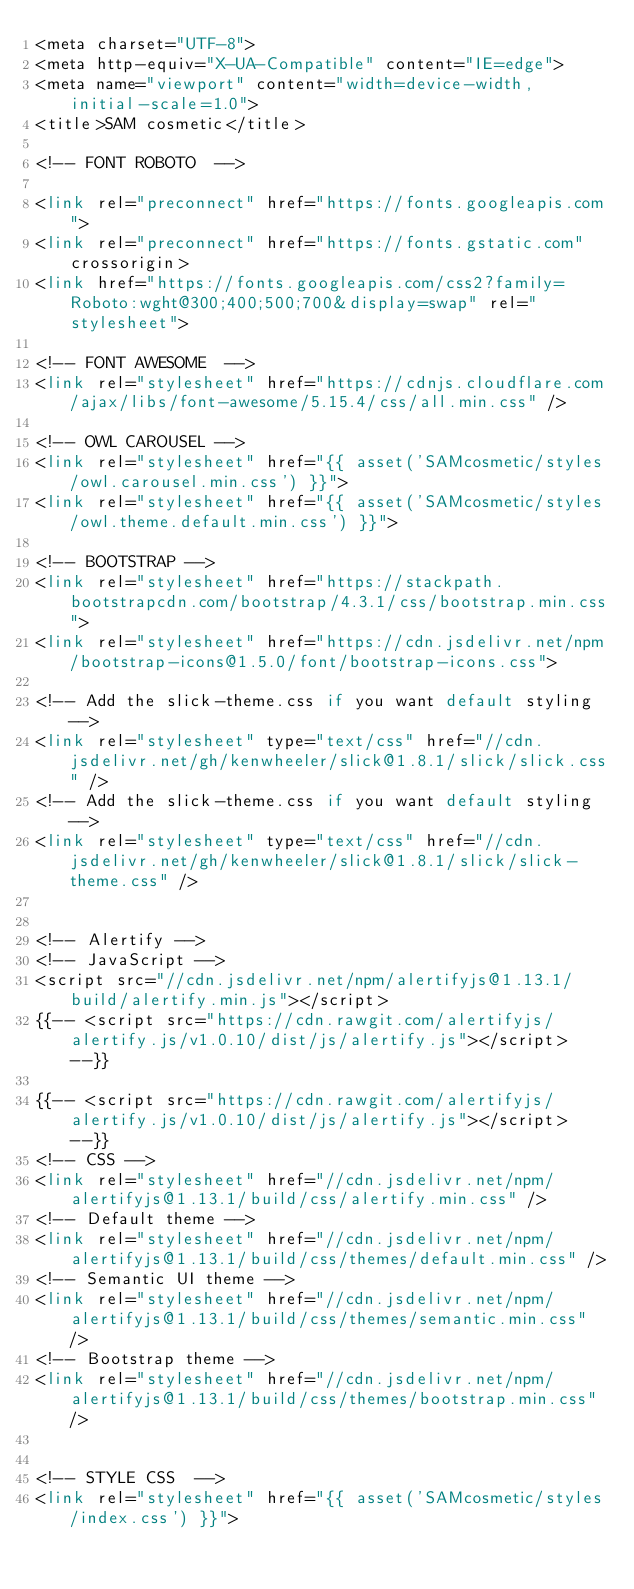Convert code to text. <code><loc_0><loc_0><loc_500><loc_500><_PHP_><meta charset="UTF-8">
<meta http-equiv="X-UA-Compatible" content="IE=edge">
<meta name="viewport" content="width=device-width, initial-scale=1.0">
<title>SAM cosmetic</title>

<!-- FONT ROBOTO  -->

<link rel="preconnect" href="https://fonts.googleapis.com">
<link rel="preconnect" href="https://fonts.gstatic.com" crossorigin>
<link href="https://fonts.googleapis.com/css2?family=Roboto:wght@300;400;500;700&display=swap" rel="stylesheet">

<!-- FONT AWESOME  -->
<link rel="stylesheet" href="https://cdnjs.cloudflare.com/ajax/libs/font-awesome/5.15.4/css/all.min.css" />

<!-- OWL CAROUSEL -->
<link rel="stylesheet" href="{{ asset('SAMcosmetic/styles/owl.carousel.min.css') }}">
<link rel="stylesheet" href="{{ asset('SAMcosmetic/styles/owl.theme.default.min.css') }}">

<!-- BOOTSTRAP -->
<link rel="stylesheet" href="https://stackpath.bootstrapcdn.com/bootstrap/4.3.1/css/bootstrap.min.css">
<link rel="stylesheet" href="https://cdn.jsdelivr.net/npm/bootstrap-icons@1.5.0/font/bootstrap-icons.css">

<!-- Add the slick-theme.css if you want default styling -->
<link rel="stylesheet" type="text/css" href="//cdn.jsdelivr.net/gh/kenwheeler/slick@1.8.1/slick/slick.css" />
<!-- Add the slick-theme.css if you want default styling -->
<link rel="stylesheet" type="text/css" href="//cdn.jsdelivr.net/gh/kenwheeler/slick@1.8.1/slick/slick-theme.css" />


<!-- Alertify -->
<!-- JavaScript -->
<script src="//cdn.jsdelivr.net/npm/alertifyjs@1.13.1/build/alertify.min.js"></script>
{{-- <script src="https://cdn.rawgit.com/alertifyjs/alertify.js/v1.0.10/dist/js/alertify.js"></script> --}}

{{-- <script src="https://cdn.rawgit.com/alertifyjs/alertify.js/v1.0.10/dist/js/alertify.js"></script> --}}
<!-- CSS -->
<link rel="stylesheet" href="//cdn.jsdelivr.net/npm/alertifyjs@1.13.1/build/css/alertify.min.css" />
<!-- Default theme -->
<link rel="stylesheet" href="//cdn.jsdelivr.net/npm/alertifyjs@1.13.1/build/css/themes/default.min.css" />
<!-- Semantic UI theme -->
<link rel="stylesheet" href="//cdn.jsdelivr.net/npm/alertifyjs@1.13.1/build/css/themes/semantic.min.css" />
<!-- Bootstrap theme -->
<link rel="stylesheet" href="//cdn.jsdelivr.net/npm/alertifyjs@1.13.1/build/css/themes/bootstrap.min.css" />


<!-- STYLE CSS  -->
<link rel="stylesheet" href="{{ asset('SAMcosmetic/styles/index.css') }}">
</code> 